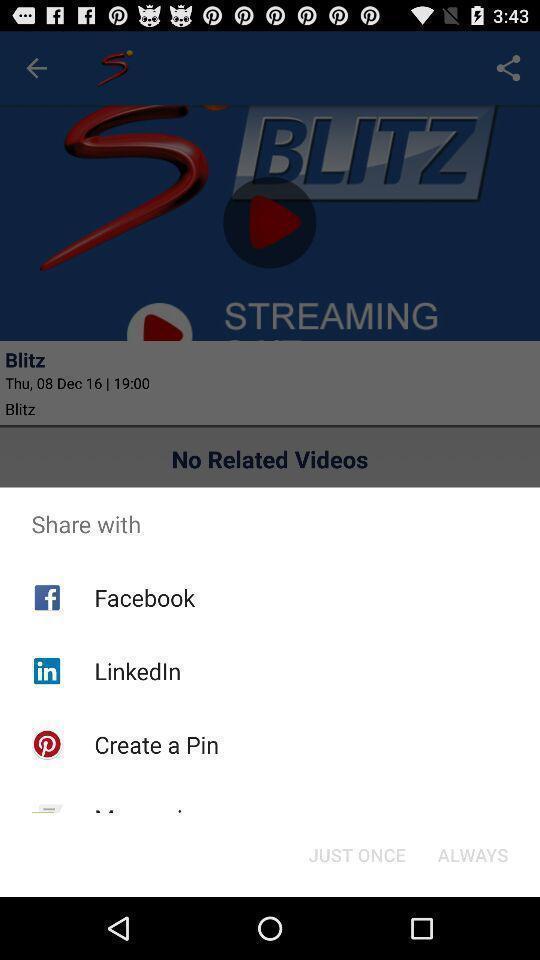Summarize the information in this screenshot. Pop-up showing various sharing options. 